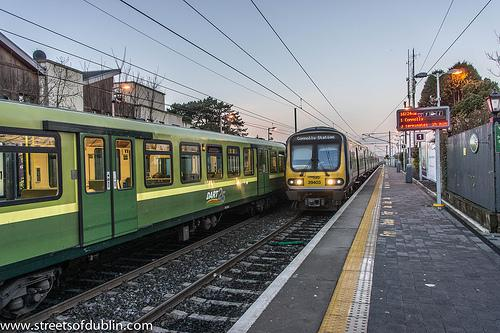Question: what color is the train on the right?
Choices:
A. Yellow.
B. Pink.
C. Red.
D. Black.
Answer with the letter. Answer: A Question: what color is the train on the left?
Choices:
A. Green.
B. White.
C. Red.
D. Black.
Answer with the letter. Answer: A Question: how many trains are seen?
Choices:
A. One.
B. Two.
C. Three.
D. Four.
Answer with the letter. Answer: B Question: where are the trains?
Choices:
A. In the depot.
B. At the garage.
C. Off the tracks.
D. On the tracks.
Answer with the letter. Answer: D 